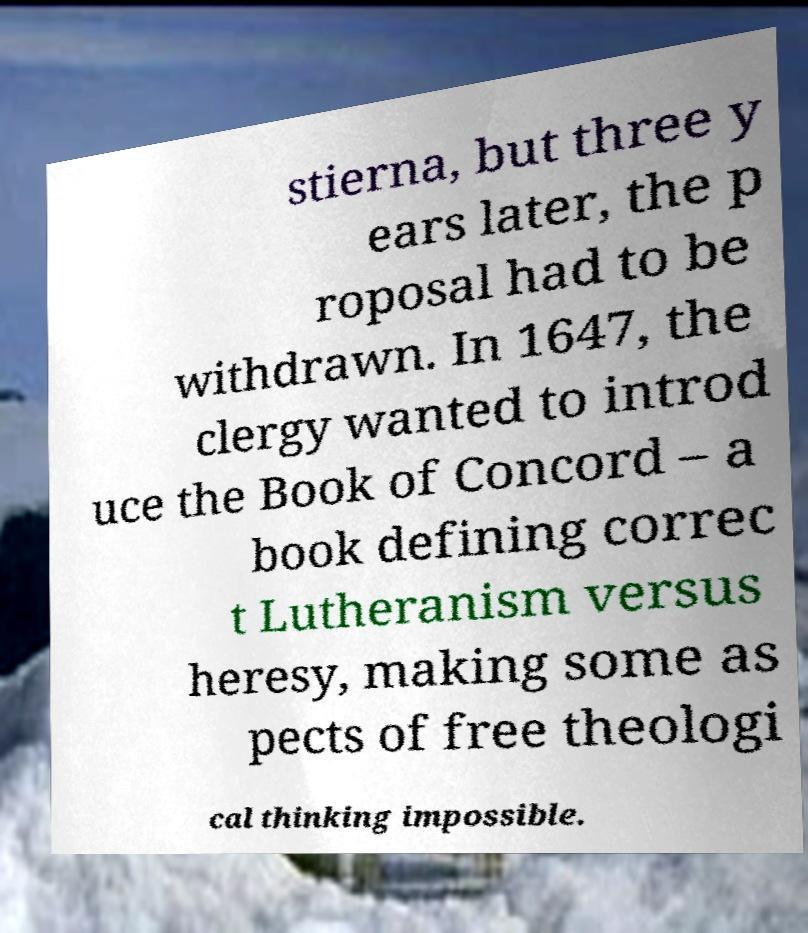Can you read and provide the text displayed in the image?This photo seems to have some interesting text. Can you extract and type it out for me? stierna, but three y ears later, the p roposal had to be withdrawn. In 1647, the clergy wanted to introd uce the Book of Concord – a book defining correc t Lutheranism versus heresy, making some as pects of free theologi cal thinking impossible. 